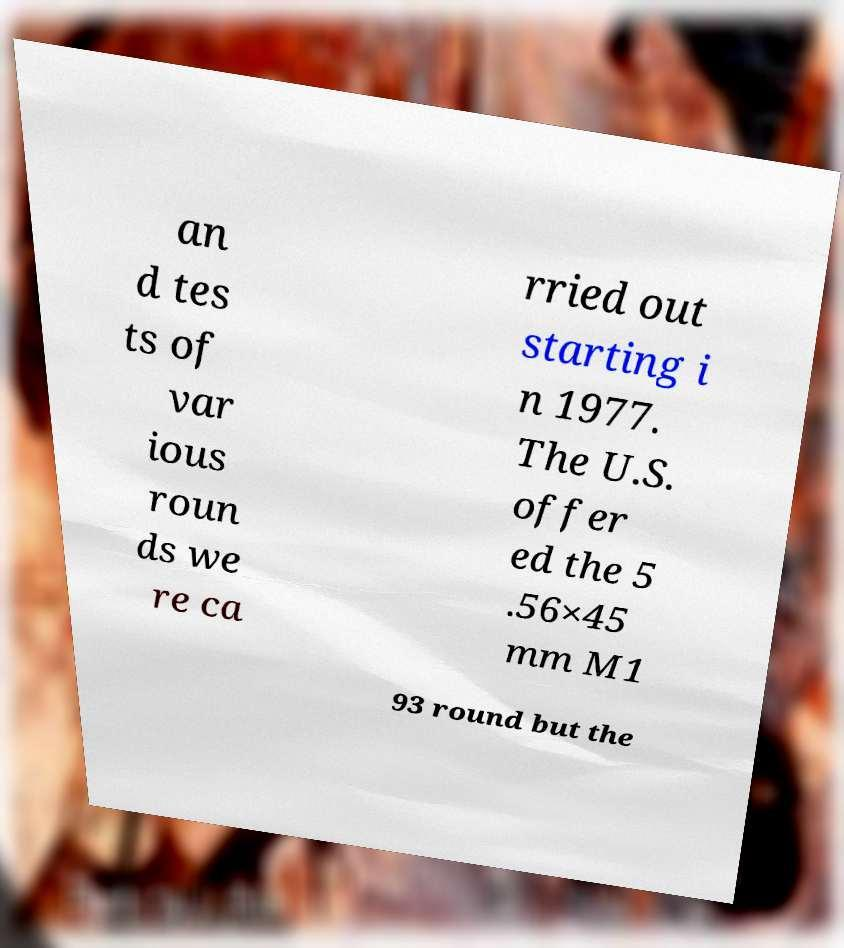Could you extract and type out the text from this image? an d tes ts of var ious roun ds we re ca rried out starting i n 1977. The U.S. offer ed the 5 .56×45 mm M1 93 round but the 